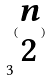<formula> <loc_0><loc_0><loc_500><loc_500>3 ^ { ( \begin{matrix} n \\ 2 \end{matrix} ) }</formula> 